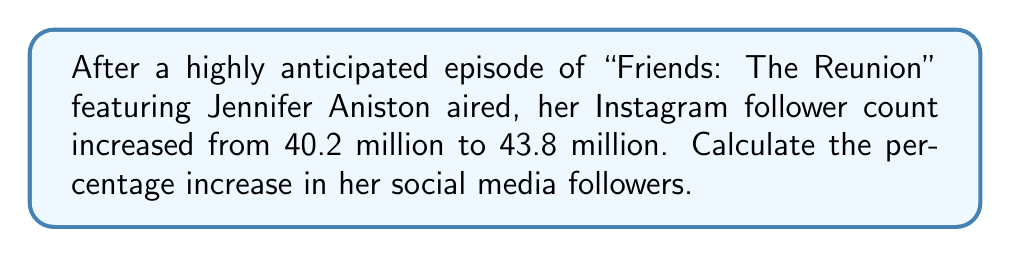Help me with this question. To calculate the percentage increase, we'll follow these steps:

1. Calculate the absolute increase in followers:
   $\text{Increase} = \text{New followers} - \text{Original followers}$
   $\text{Increase} = 43.8 \text{ million} - 40.2 \text{ million} = 3.6 \text{ million}$

2. Calculate the percentage increase using the formula:
   $$\text{Percentage increase} = \frac{\text{Increase}}{\text{Original value}} \times 100\%$$

3. Substitute the values:
   $$\text{Percentage increase} = \frac{3.6 \text{ million}}{40.2 \text{ million}} \times 100\%$$

4. Simplify:
   $$\text{Percentage increase} = \frac{3.6}{40.2} \times 100\% = 0.08955 \times 100\% = 8.955\%$$

5. Round to two decimal places:
   $$\text{Percentage increase} \approx 8.96\%$$
Answer: 8.96% 